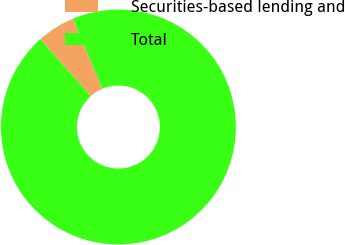Convert chart to OTSL. <chart><loc_0><loc_0><loc_500><loc_500><pie_chart><fcel>Securities-based lending and<fcel>Total<nl><fcel>5.26%<fcel>94.74%<nl></chart> 